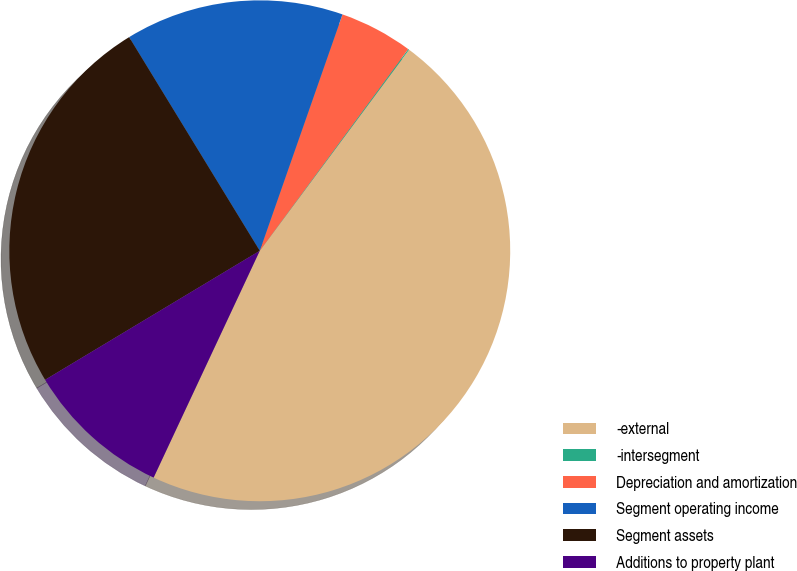Convert chart. <chart><loc_0><loc_0><loc_500><loc_500><pie_chart><fcel>-external<fcel>-intersegment<fcel>Depreciation and amortization<fcel>Segment operating income<fcel>Segment assets<fcel>Additions to property plant<nl><fcel>46.8%<fcel>0.07%<fcel>4.74%<fcel>14.09%<fcel>24.88%<fcel>9.42%<nl></chart> 